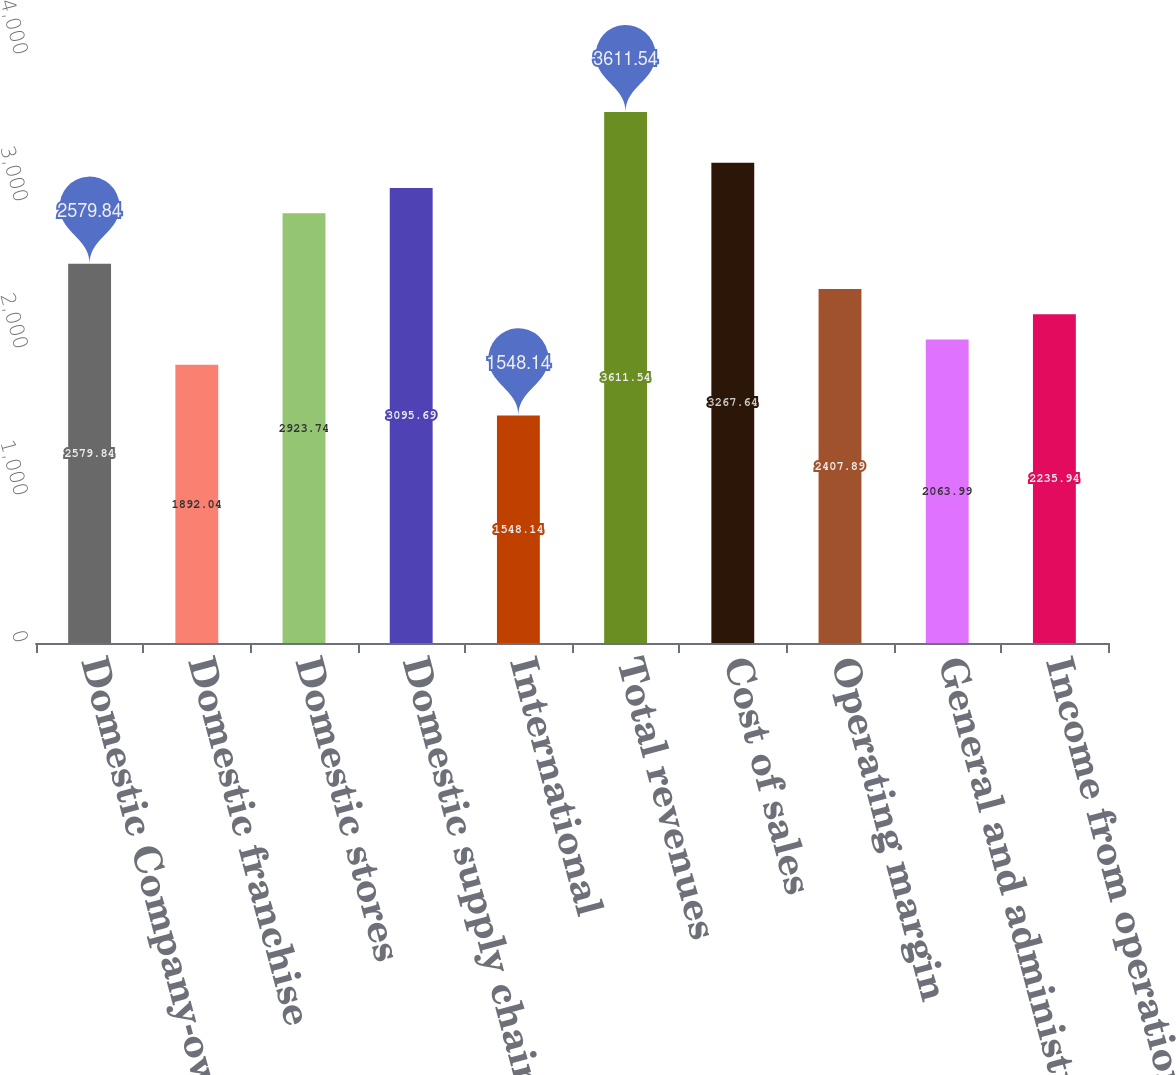<chart> <loc_0><loc_0><loc_500><loc_500><bar_chart><fcel>Domestic Company-owned stores<fcel>Domestic franchise<fcel>Domestic stores<fcel>Domestic supply chain<fcel>International<fcel>Total revenues<fcel>Cost of sales<fcel>Operating margin<fcel>General and administrative<fcel>Income from operations<nl><fcel>2579.84<fcel>1892.04<fcel>2923.74<fcel>3095.69<fcel>1548.14<fcel>3611.54<fcel>3267.64<fcel>2407.89<fcel>2063.99<fcel>2235.94<nl></chart> 